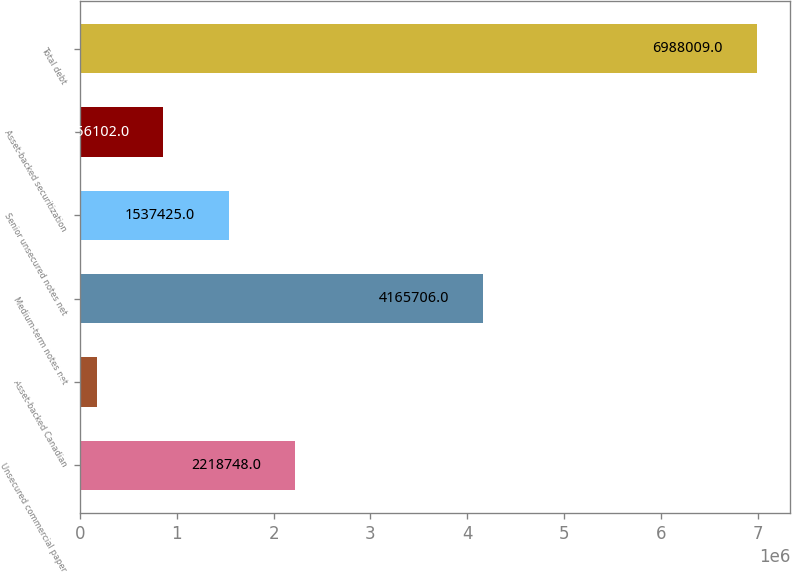Convert chart to OTSL. <chart><loc_0><loc_0><loc_500><loc_500><bar_chart><fcel>Unsecured commercial paper<fcel>Asset-backed Canadian<fcel>Medium-term notes net<fcel>Senior unsecured notes net<fcel>Asset-backed securitization<fcel>Total debt<nl><fcel>2.21875e+06<fcel>174779<fcel>4.16571e+06<fcel>1.53742e+06<fcel>856102<fcel>6.98801e+06<nl></chart> 